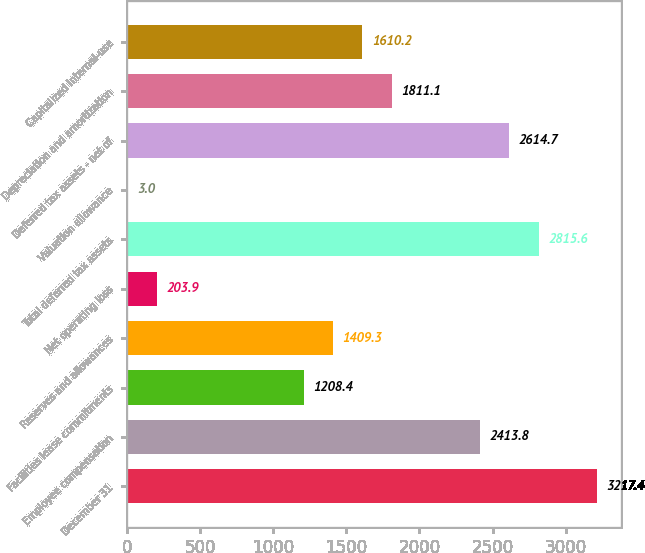<chart> <loc_0><loc_0><loc_500><loc_500><bar_chart><fcel>December 31<fcel>Employee compensation<fcel>Facilities lease commitments<fcel>Reserves and allowances<fcel>Net operating loss<fcel>Total deferred tax assets<fcel>Valuation allowance<fcel>Deferred tax assets - net of<fcel>Depreciation and amortization<fcel>Capitalized internal-use<nl><fcel>3217.4<fcel>2413.8<fcel>1208.4<fcel>1409.3<fcel>203.9<fcel>2815.6<fcel>3<fcel>2614.7<fcel>1811.1<fcel>1610.2<nl></chart> 